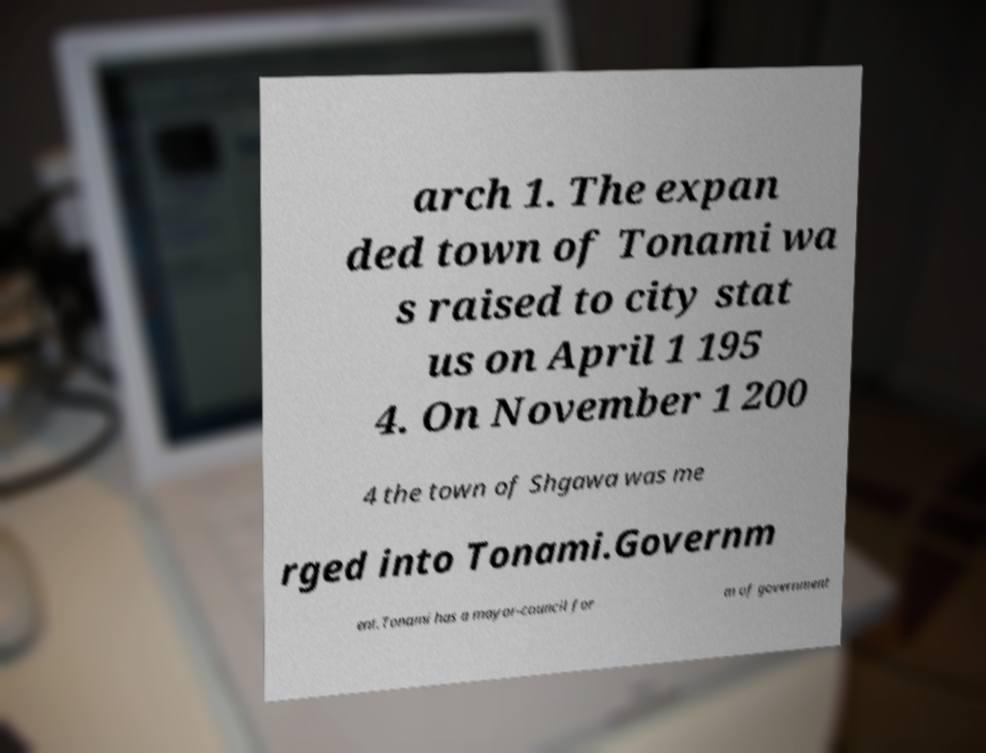Could you extract and type out the text from this image? arch 1. The expan ded town of Tonami wa s raised to city stat us on April 1 195 4. On November 1 200 4 the town of Shgawa was me rged into Tonami.Governm ent.Tonami has a mayor-council for m of government 